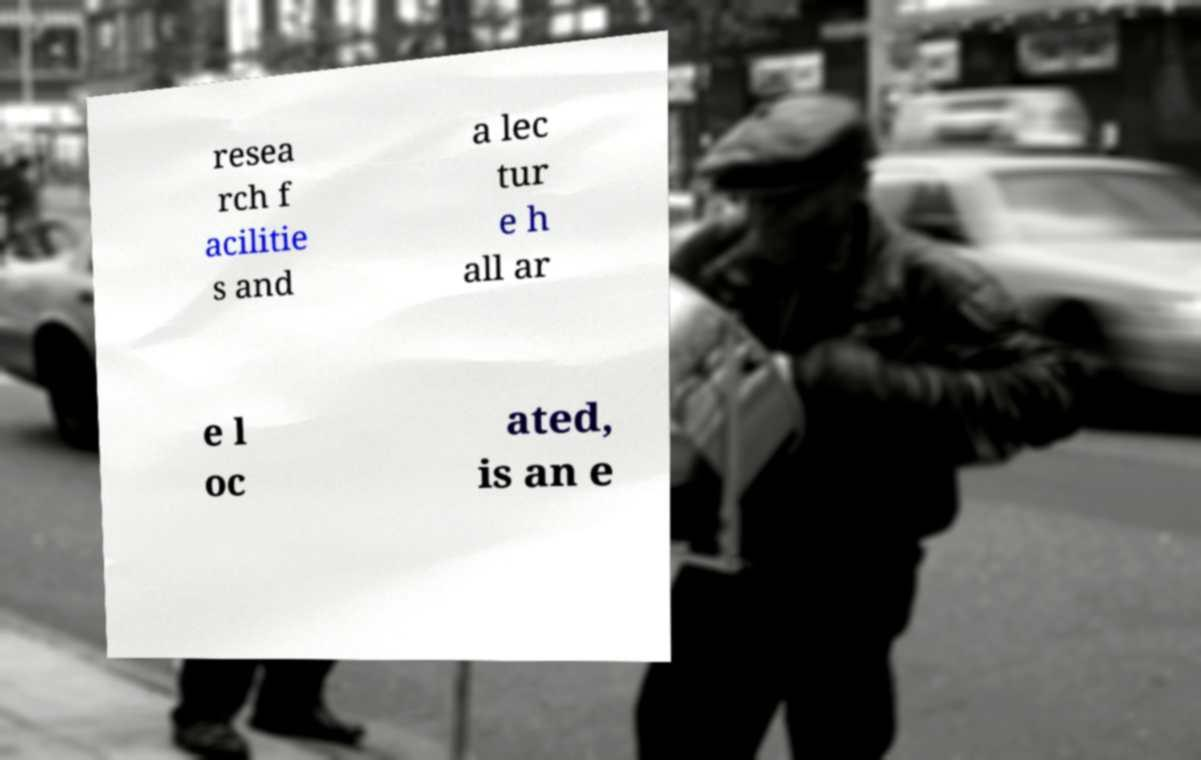Please read and relay the text visible in this image. What does it say? resea rch f acilitie s and a lec tur e h all ar e l oc ated, is an e 